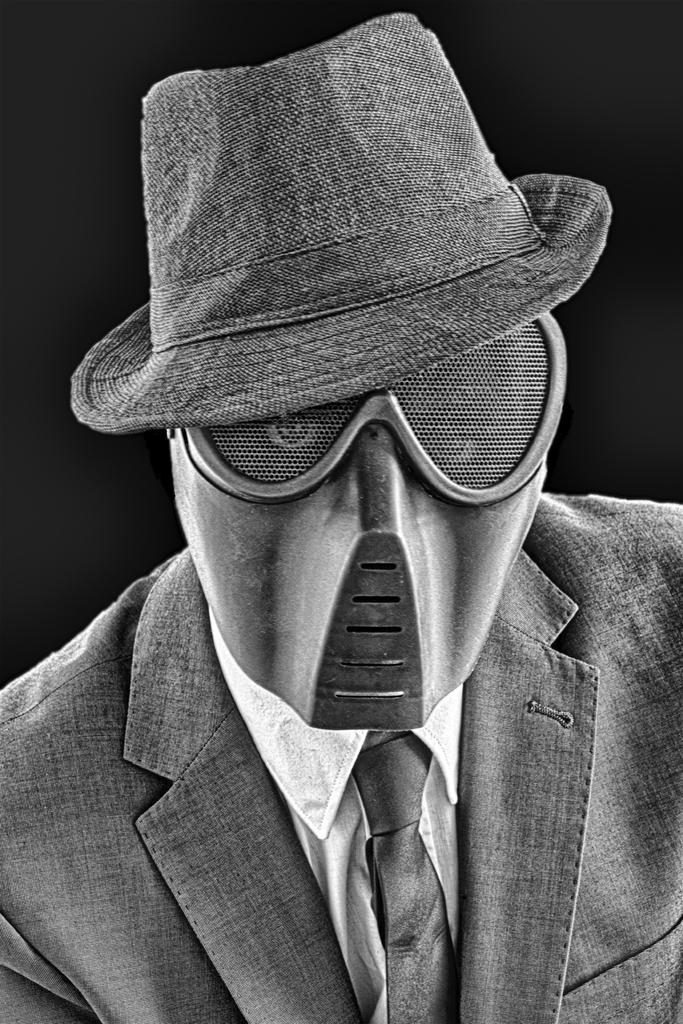Who or what is present in the image? There is a person in the image. What is the person wearing on their head? The person is wearing a cap. What is the person wearing to cover their face? The person is wearing a mask. What type of fang can be seen in the person's mouth in the image? There is no fang visible in the person's mouth in the image. What form does the person's body take in the image? The person's body takes a human form in the image. 